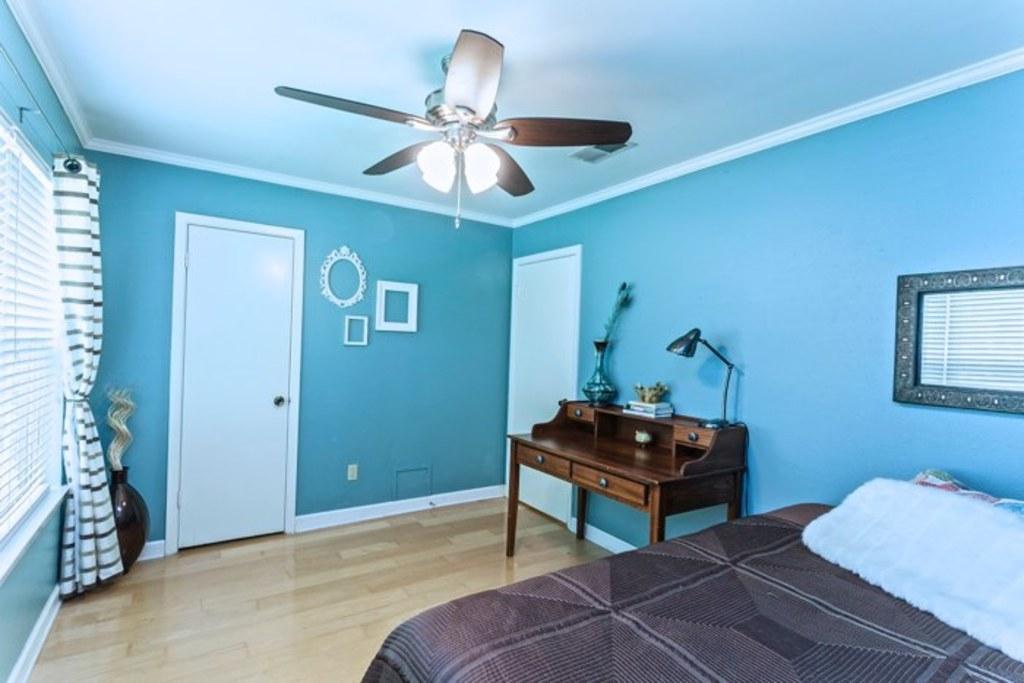Can you describe this image briefly? In this image there is a view of the bedroom, there is a bed, there is a table, there is a light on the table, there are objectś on the table, there is a fan, there are doorś, there is a window, there is a curtain, there is white roof, there are lightś attached to the fan, there is a pillow, blanket on the bed. 